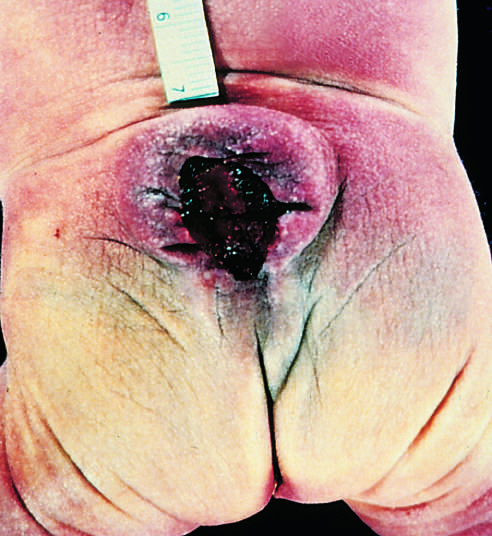re histologic features of the chancre included in the cystlike structure visible just above the buttocks?
Answer the question using a single word or phrase. No 